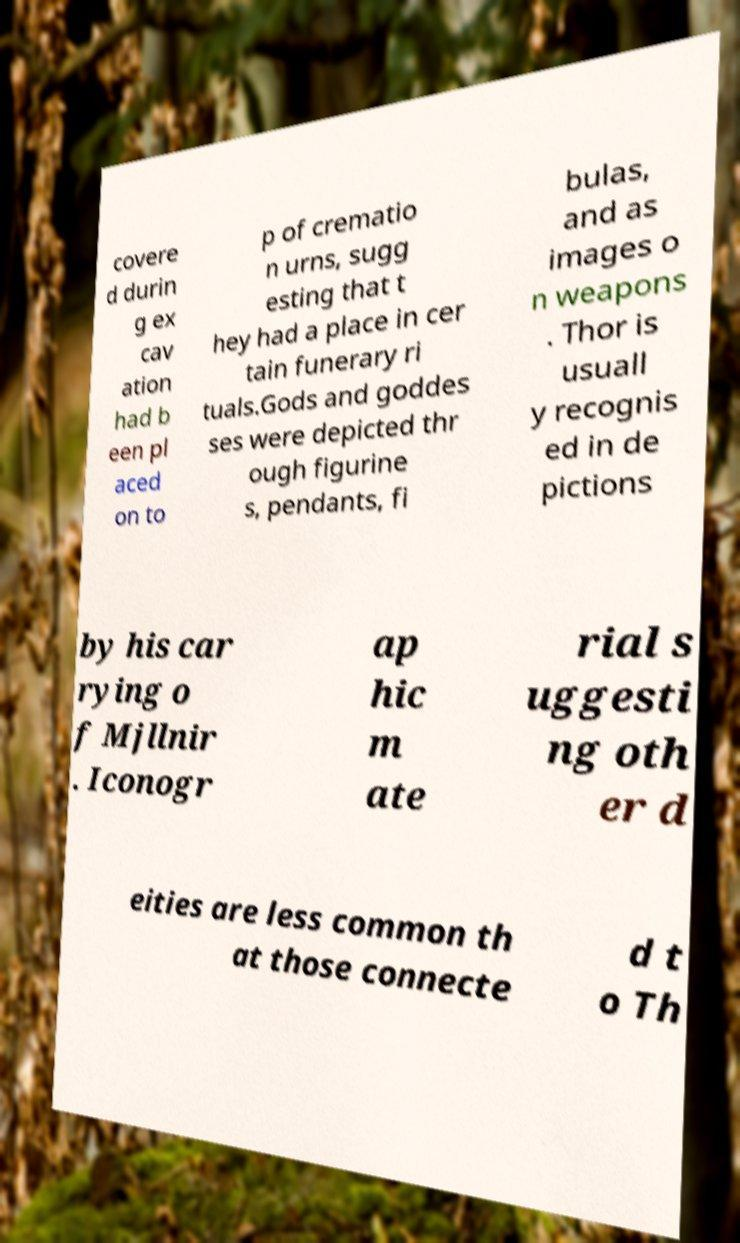What messages or text are displayed in this image? I need them in a readable, typed format. covere d durin g ex cav ation had b een pl aced on to p of crematio n urns, sugg esting that t hey had a place in cer tain funerary ri tuals.Gods and goddes ses were depicted thr ough figurine s, pendants, fi bulas, and as images o n weapons . Thor is usuall y recognis ed in de pictions by his car rying o f Mjllnir . Iconogr ap hic m ate rial s uggesti ng oth er d eities are less common th at those connecte d t o Th 